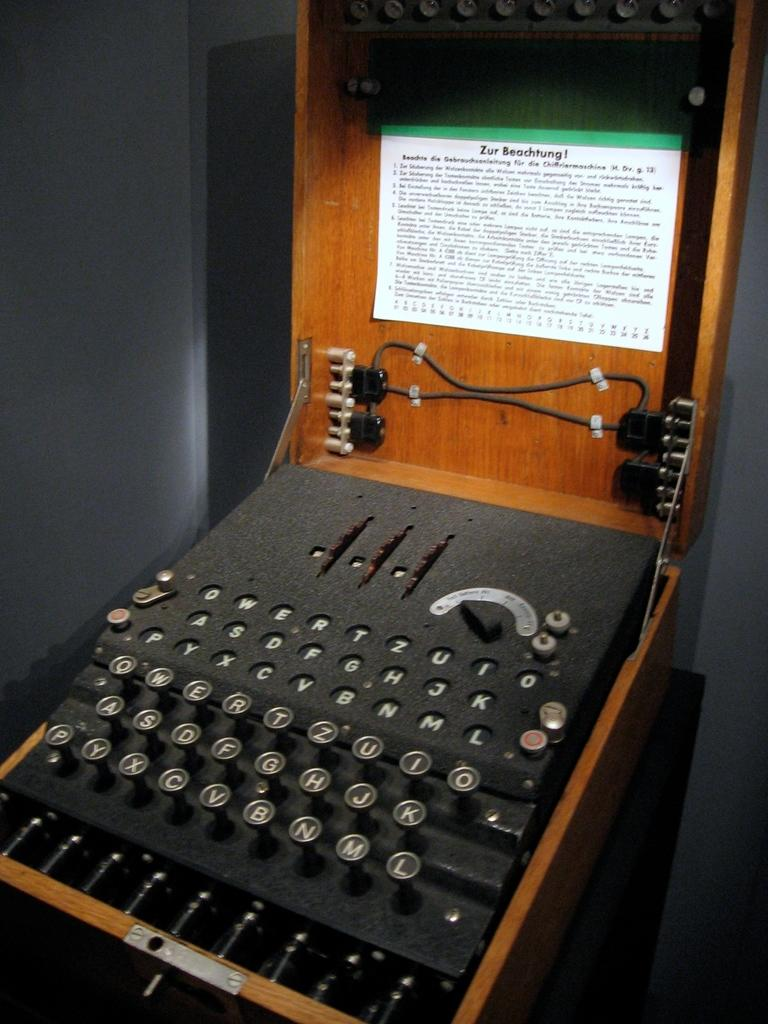What is the main object in the center of the image? There is a typewriting machine in the center of the image. What can be seen in the background of the image? There is a wall in the background of the image. What type of crops is the farmer growing in the patch visible in the image? There is no farmer or crops present in the image; it features a typewriting machine and a wall. 